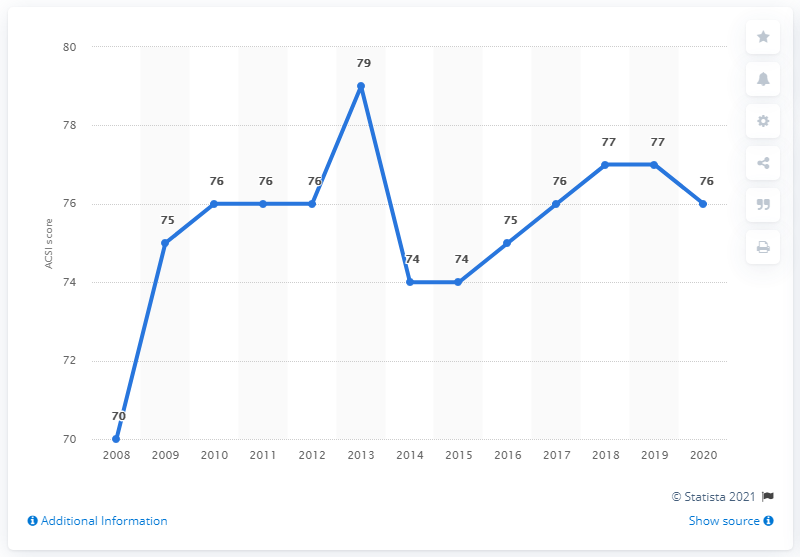Mention a couple of crucial points in this snapshot. According to the American Customer Satisfaction Index score in 2020, Best Western received a rating of 76. In 2013, Best Western received a score of 79, which was its highest rating that year. 